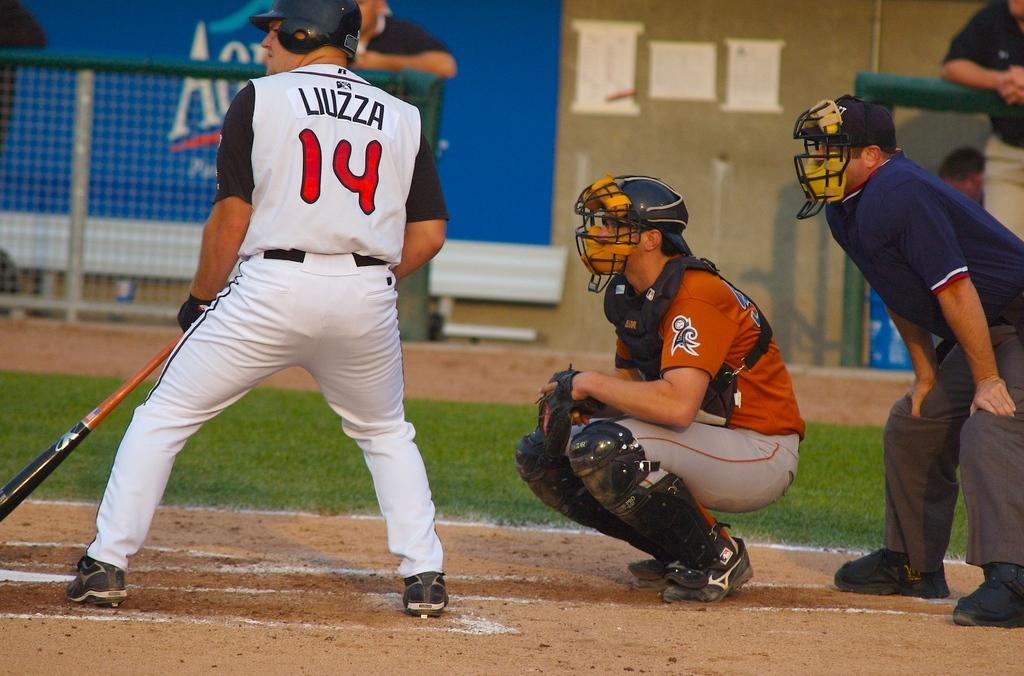<image>
Create a compact narrative representing the image presented. Baseball player at home plate that is batting with the name Liuzza # 14. 